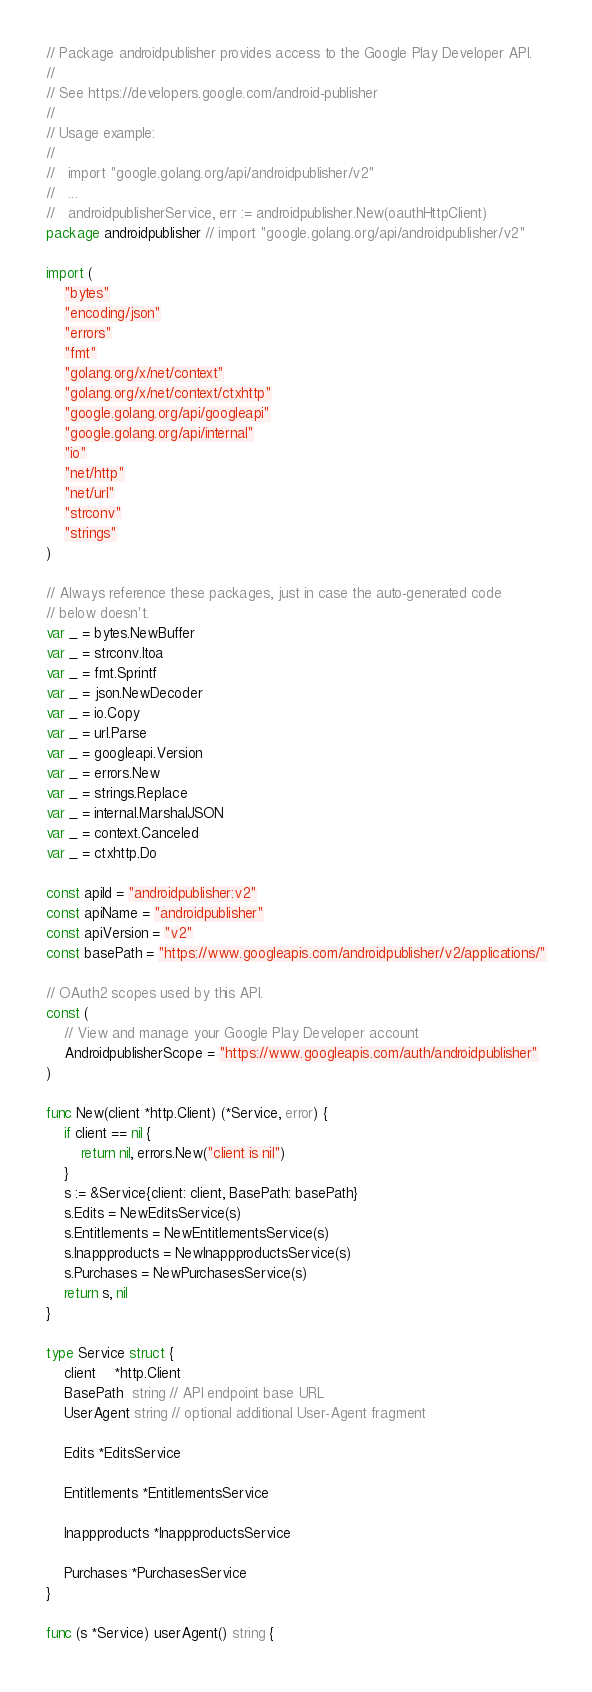<code> <loc_0><loc_0><loc_500><loc_500><_Go_>// Package androidpublisher provides access to the Google Play Developer API.
//
// See https://developers.google.com/android-publisher
//
// Usage example:
//
//   import "google.golang.org/api/androidpublisher/v2"
//   ...
//   androidpublisherService, err := androidpublisher.New(oauthHttpClient)
package androidpublisher // import "google.golang.org/api/androidpublisher/v2"

import (
	"bytes"
	"encoding/json"
	"errors"
	"fmt"
	"golang.org/x/net/context"
	"golang.org/x/net/context/ctxhttp"
	"google.golang.org/api/googleapi"
	"google.golang.org/api/internal"
	"io"
	"net/http"
	"net/url"
	"strconv"
	"strings"
)

// Always reference these packages, just in case the auto-generated code
// below doesn't.
var _ = bytes.NewBuffer
var _ = strconv.Itoa
var _ = fmt.Sprintf
var _ = json.NewDecoder
var _ = io.Copy
var _ = url.Parse
var _ = googleapi.Version
var _ = errors.New
var _ = strings.Replace
var _ = internal.MarshalJSON
var _ = context.Canceled
var _ = ctxhttp.Do

const apiId = "androidpublisher:v2"
const apiName = "androidpublisher"
const apiVersion = "v2"
const basePath = "https://www.googleapis.com/androidpublisher/v2/applications/"

// OAuth2 scopes used by this API.
const (
	// View and manage your Google Play Developer account
	AndroidpublisherScope = "https://www.googleapis.com/auth/androidpublisher"
)

func New(client *http.Client) (*Service, error) {
	if client == nil {
		return nil, errors.New("client is nil")
	}
	s := &Service{client: client, BasePath: basePath}
	s.Edits = NewEditsService(s)
	s.Entitlements = NewEntitlementsService(s)
	s.Inappproducts = NewInappproductsService(s)
	s.Purchases = NewPurchasesService(s)
	return s, nil
}

type Service struct {
	client    *http.Client
	BasePath  string // API endpoint base URL
	UserAgent string // optional additional User-Agent fragment

	Edits *EditsService

	Entitlements *EntitlementsService

	Inappproducts *InappproductsService

	Purchases *PurchasesService
}

func (s *Service) userAgent() string {</code> 